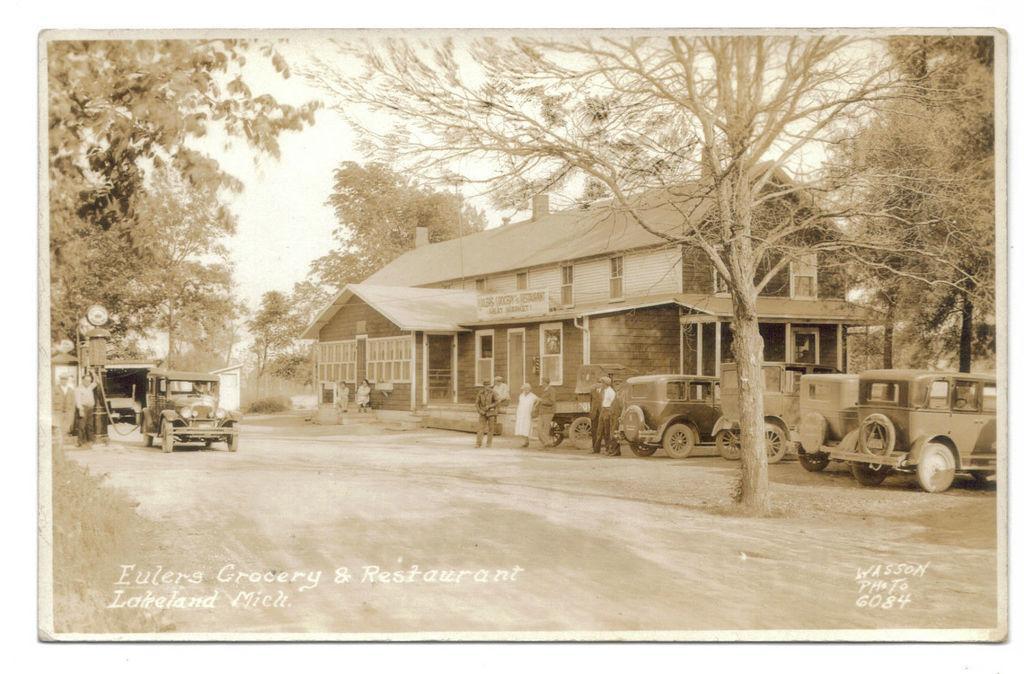Please provide a concise description of this image. In this picture I can see a building and I can see vehicles, trees and few people walking and couple of them standing and I can see text at the bottom of the picture and I can see sky. 